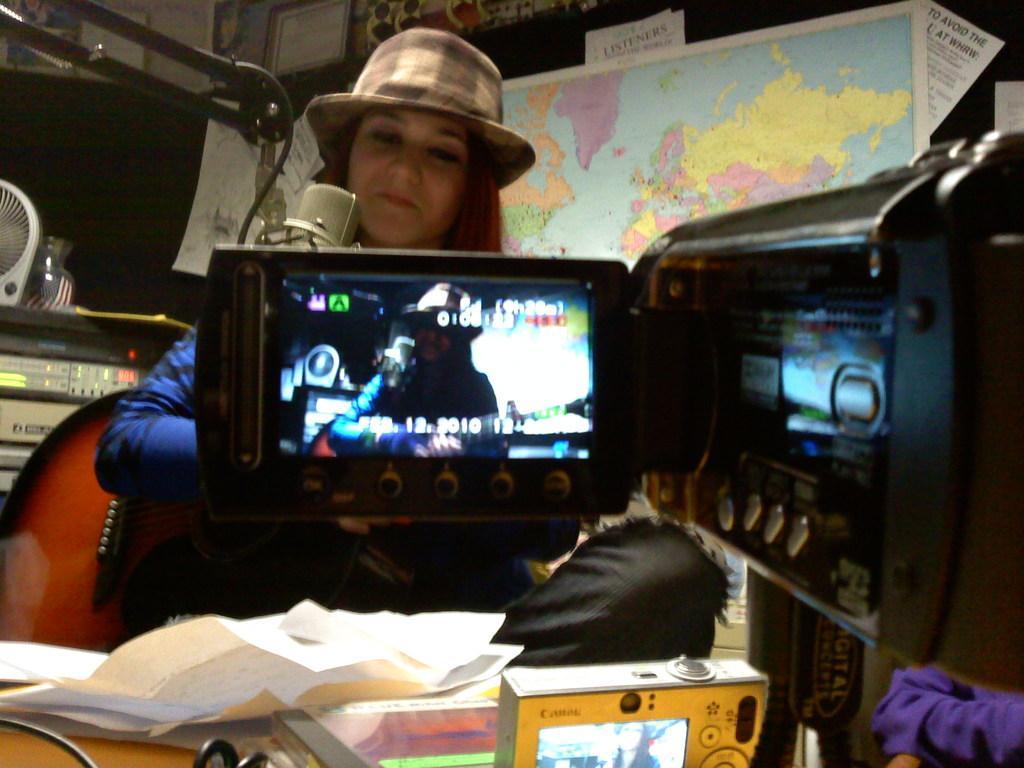In one or two sentences, can you explain what this image depicts? In the middle of the image there is a camera. Behind the camera a woman is sitting and holding a guitar. At the top of the image there is a wall, on the wall there are some posters and maps. At the bottom of the image there is a table, on the table there are some papers. 